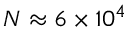Convert formula to latex. <formula><loc_0><loc_0><loc_500><loc_500>N \approx 6 \times 1 0 ^ { 4 }</formula> 